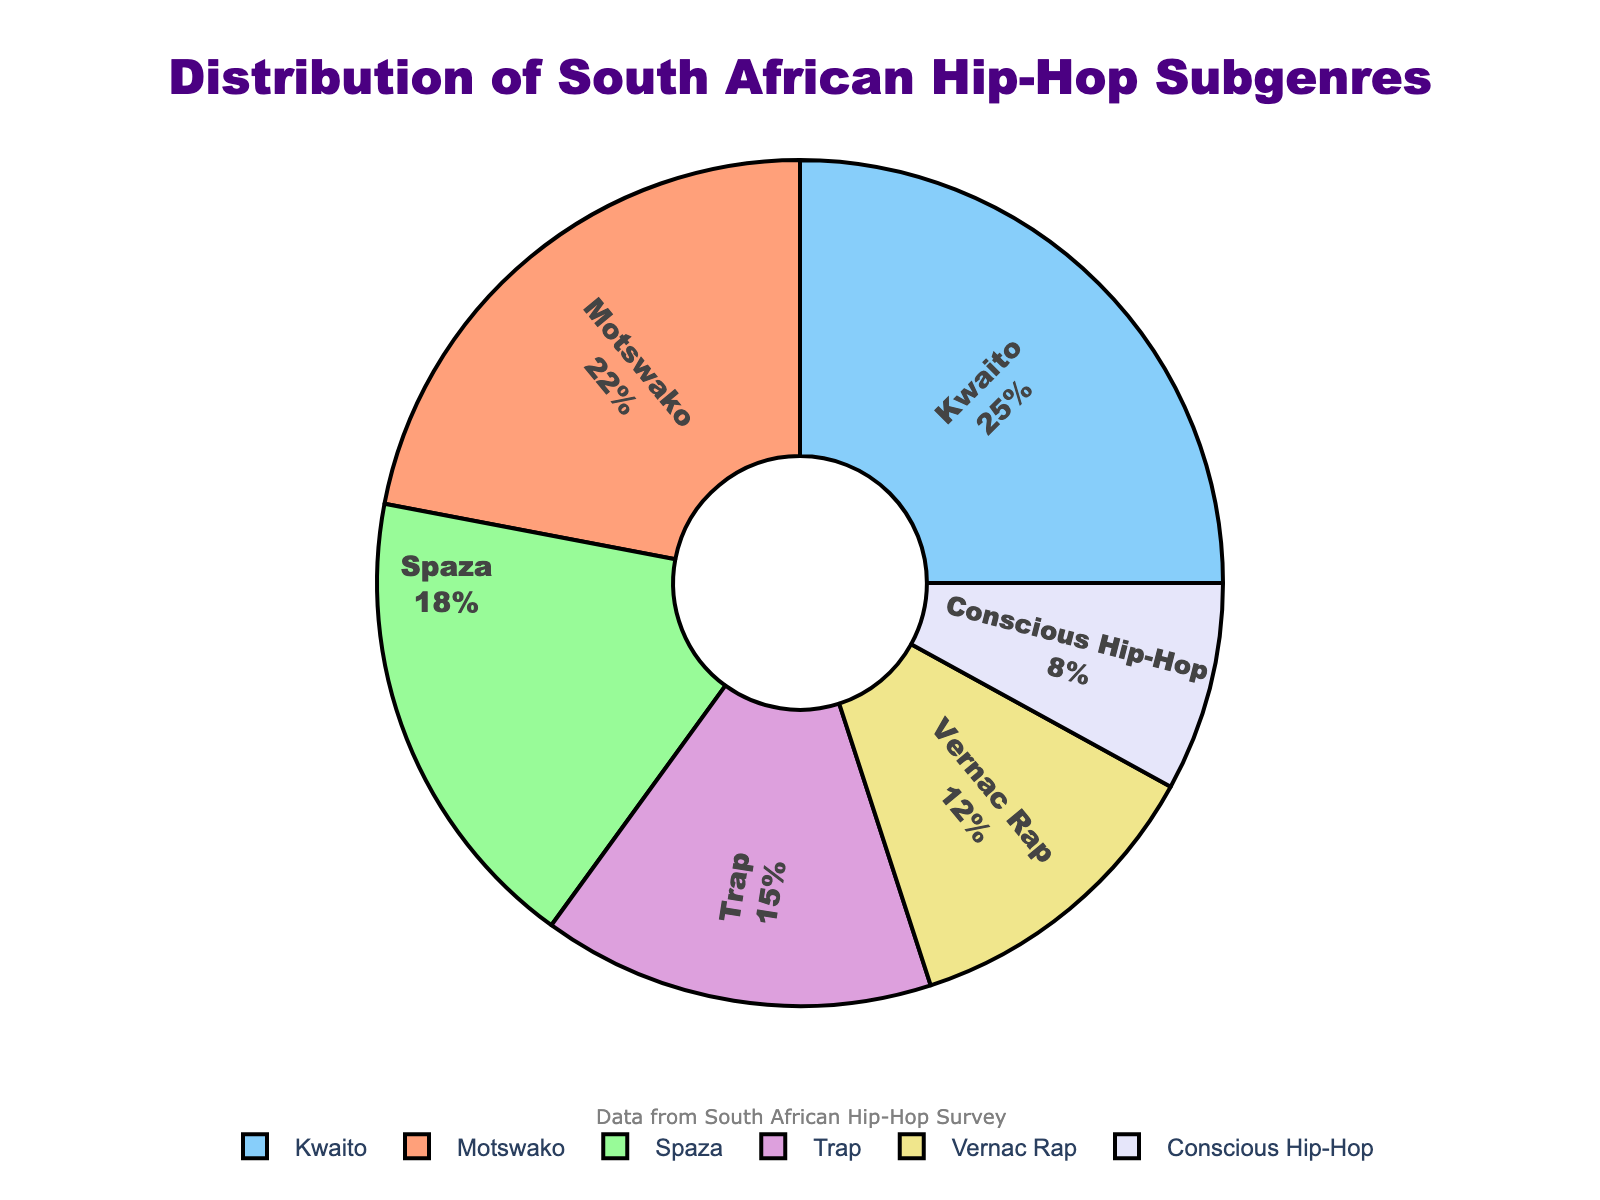what is the most popular subgenre of South African hip-hop? The pie chart shows that Kwaito has the largest percentage among all the subgenres. The visual clearly indicates that Kwaito takes up the biggest share.
Answer: Kwaito What subgenre has the smallest percentage? By looking at the pie chart, it becomes evident that Conscious Hip-Hop has the smallest segment. It visually occupies the least space in the chart.
Answer: Conscious Hip-Hop What is the combined percentage of Spaza and Trap? To find the combined percentage, add the percentages of Spaza and Trap subgenres: 18% (Spaza) + 15% (Trap) = 33%.
Answer: 33% Is the percentage of Kwaito greater than the sum of Vernac Rap and Conscious Hip-Hop? The percentage of Kwaito is 25%. Vernac Rap and Conscious Hip-Hop together equal 12% + 8% = 20%. Since 25% is greater than 20%, the answer is yes.
Answer: Yes What subgenre contributes more to the total music share, Motswako or Spaza? Comparing the percentages of Motswako (22%) and Spaza (18%), Motswako has a higher percentage.
Answer: Motswako How much more popular is Kwaito compared to Conscious Hip-Hop? Kwaito has 25% and Conscious Hip-Hop has 8%. The difference in popularity is 25% - 8% = 17%.
Answer: 17% What is the average percentage of all subgenres presented in the pie chart? To find the average, sum all the percentages and divide by the number of subgenres: (22% + 18% + 25% + 15% + 12% + 8%) / 6 = 100% / 6 ≈ 16.67%.
Answer: 16.67% Which subgenre has a larger share, Vernac Rap or Trap? According to the pie chart, Vernac Rap is at 12% and Trap is at 15%. Therefore, Trap has a larger share.
Answer: Trap If you were to combine Motswako and Kwaito, what percentage of the total would they represent? Adding the percentages of Motswako and Kwaito: 22% (Motswako) + 25% (Kwaito) = 47%.
Answer: 47% What relative proportion does Trap hold within the hip-hop subgenres distribution? Trap represents 15% of the total pie. Relative to the 100% total, its proportion is 15%.
Answer: 15% 